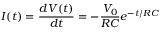<formula> <loc_0><loc_0><loc_500><loc_500>I ( t ) = \frac { d V ( t ) } { d t } = - \frac { V _ { 0 } } { R C } e ^ { - t / R C }</formula> 